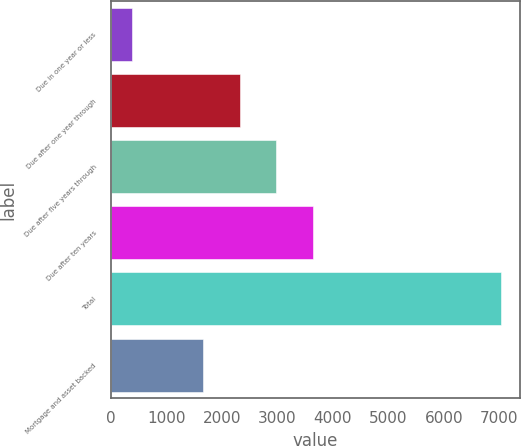Convert chart to OTSL. <chart><loc_0><loc_0><loc_500><loc_500><bar_chart><fcel>Due in one year or less<fcel>Due after one year through<fcel>Due after five years through<fcel>Due after ten years<fcel>Total<fcel>Mortgage and asset backed<nl><fcel>386<fcel>2318.9<fcel>2982.8<fcel>3646.7<fcel>7025<fcel>1655<nl></chart> 